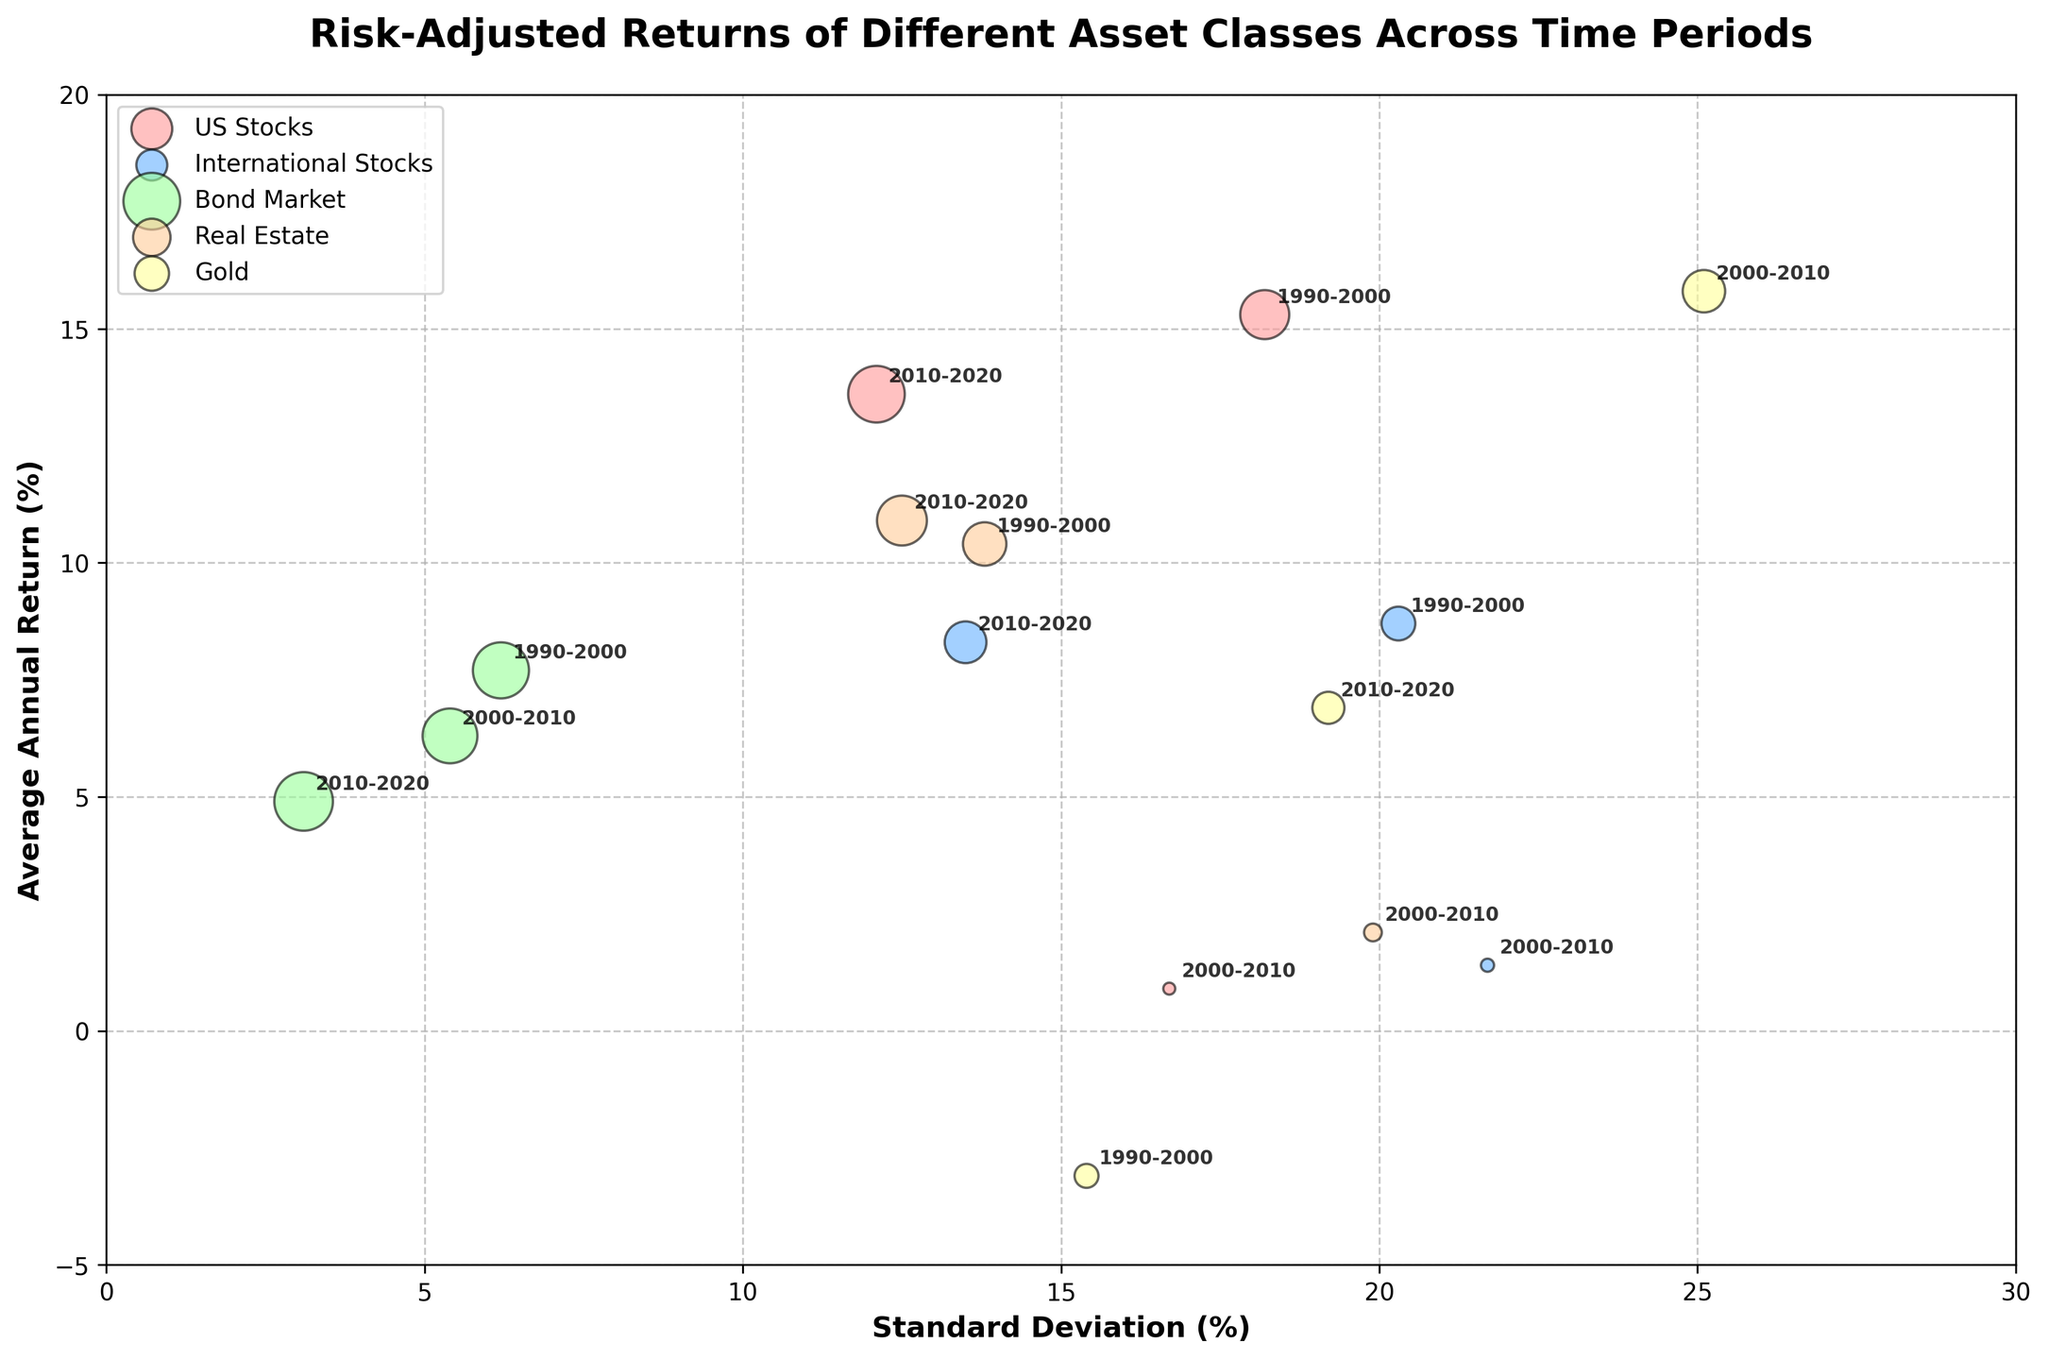What is the title of the figure? The title is displayed at the top of the figure. It reads "Risk-Adjusted Returns of Different Asset Classes Across Time Periods".
Answer: Risk-Adjusted Returns of Different Asset Classes Across Time Periods Which asset class has the highest average annual return in the 2000-2010 period? By looking at the y-axis (Average Annual Return) and the labels attached to the bubbles for the 2000-2010 period, "Gold" has the highest average annual return.
Answer: Gold What is the range of the y-axis in the figure? The y-axis range can be determined from the axis itself, which shows values starting from -5% to 20%.
Answer: -5% to 20% Which asset class has a bubble with the largest size (Sharpe Ratio) in the 2010-2020 period? Bubble size corresponds to the Sharpe Ratio. By observing the bubbles and their annotations, "Bond Market" has the largest bubble size in the 2010-2020 period.
Answer: Bond Market Which data points reflect the highest and lowest Sharpe Ratios, and which asset classes do they represent? The largest bubble would reflect the highest Sharpe Ratio and the smallest bubble the lowest. The largest bubble is "Bond Market, 2010-2020" with a Sharpe Ratio of 1.20 and the smallest bubble is "Gold, 1990-2000" with a Sharpe Ratio of -0.20.
Answer: Bond Market, 2010-2020 and Gold, 1990-2000 How does the Standard Deviation of 'US Stocks' compare between the periods 1990-2000 and 2010-2020? By locating the bubbles for 'US Stocks' and checking the x-axis (Standard Deviation), the value in the period 1990-2000 is 18.2% and in 2010-2020 is 12.1%. Thus, 1990-2000 has a higher Standard Deviation.
Answer: Higher in 1990-2000 What are the colors used to represent the different asset classes? The bubble colors represent different asset classes. They are: US Stocks (light red), International Stocks (light blue), Bond Market (light green), Real Estate (light orange), Gold (light yellow).
Answer: Red, Blue, Green, Orange, Yellow Which asset class and time period has the lowest maximum drawdown? The Max Drawdown is indicated with labels and relates to the bubble annotations. The lowest drawdown is -2.9% for "Bond Market, 2010-2020".
Answer: Bond Market, 2010-2020 For 'International Stocks', which time period had the highest average annual return, and what was the value? By looking at the y-axis values for 'International Stocks'. The highest value for 'International Stocks' is in 1990-2000, with an average annual return of 8.7%.
Answer: 1990-2000, 8.7% Which period had the highest Sharpe Ratio for 'US Stocks'? By examining bubble size and the Sharpe Ratio for 'US Stocks', the period with the highest Sharpe Ratio is 2010-2020 with a value of 1.12.
Answer: 2010-2020 